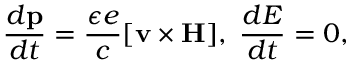Convert formula to latex. <formula><loc_0><loc_0><loc_500><loc_500>{ \frac { d { p } } { d t } } = { \frac { \epsilon e } { c } } [ { v } \times { H } ] , \, { \frac { d E } { d t } } = 0 ,</formula> 